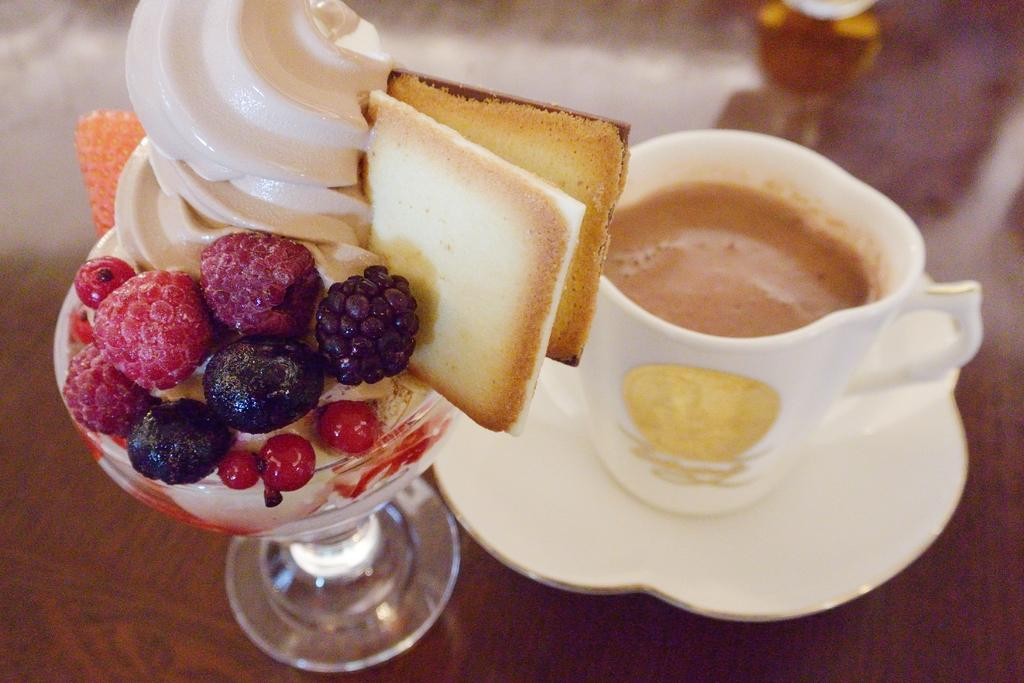What is placed on the wooden surface in the image? There is a cup, a saucer, and an ice cream on the wooden surface in the image. What is the ice cream garnished with? The ice cream has garnishing. What is the object at the top of the image? The object at the top of the image is not clear from the provided facts. What hobbies does the zebra in the image enjoy? There is no zebra present in the image, so it is not possible to determine its hobbies. 